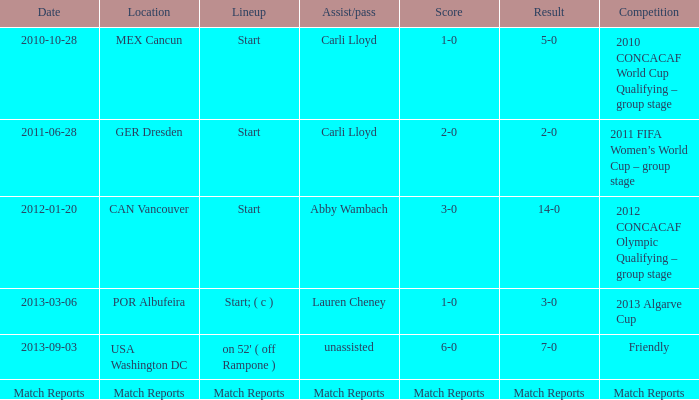Name the Result of the Lineup of start, an Assist/pass of carli lloyd, and an Competition of 2011 fifa women’s world cup – group stage? 2-0. 